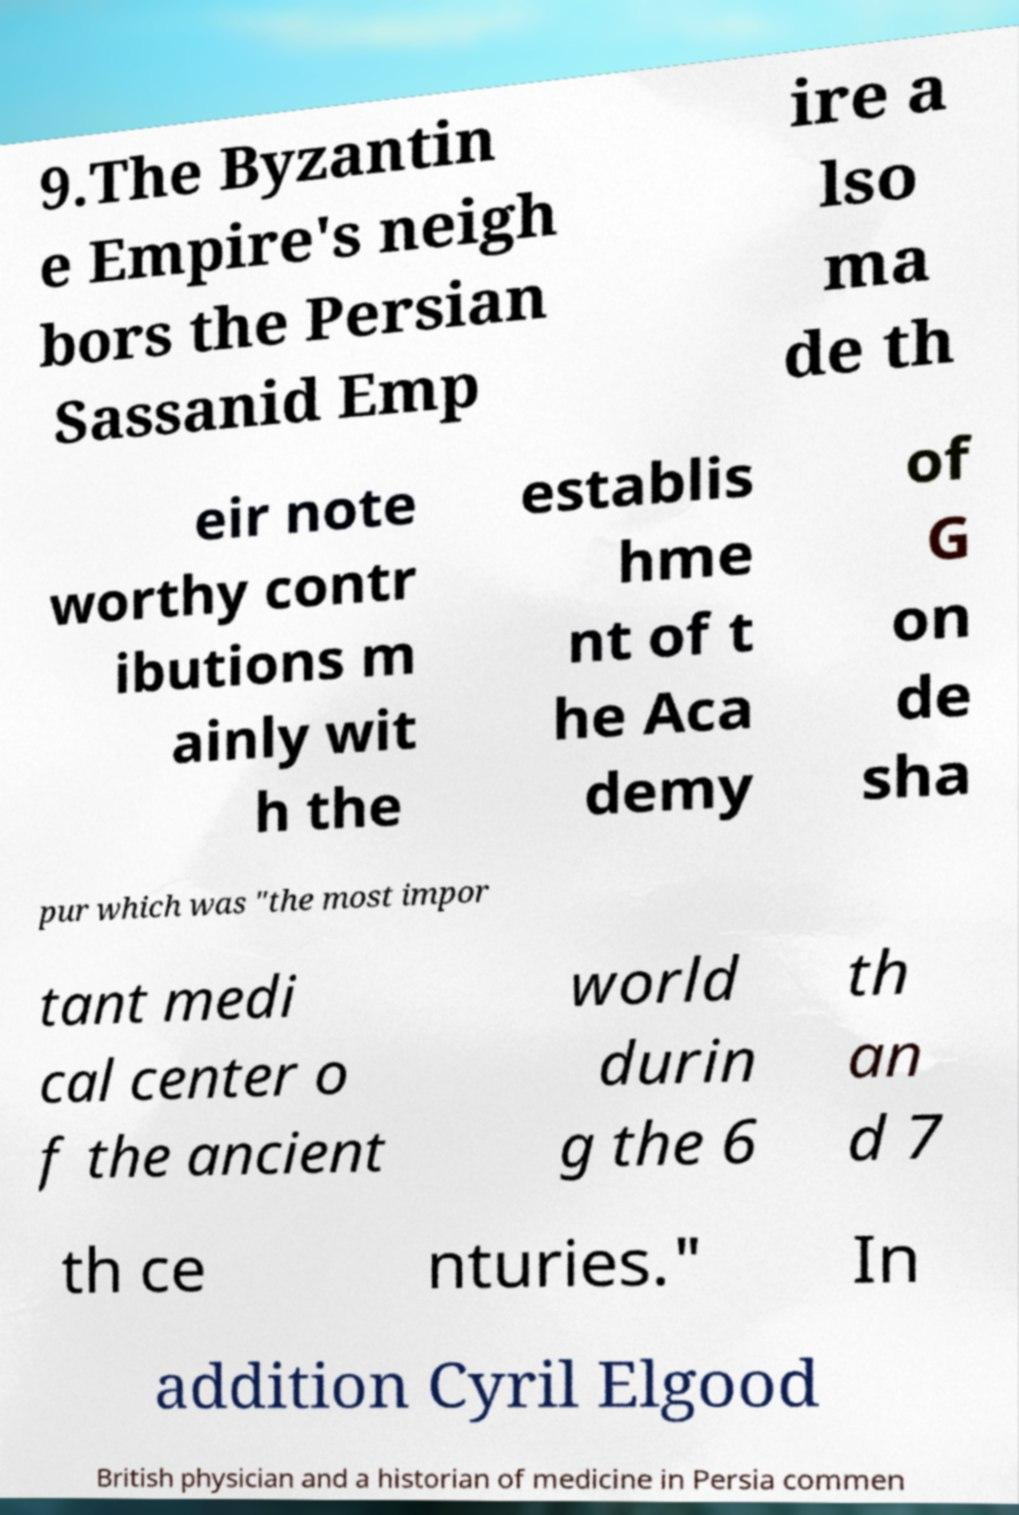I need the written content from this picture converted into text. Can you do that? 9.The Byzantin e Empire's neigh bors the Persian Sassanid Emp ire a lso ma de th eir note worthy contr ibutions m ainly wit h the establis hme nt of t he Aca demy of G on de sha pur which was "the most impor tant medi cal center o f the ancient world durin g the 6 th an d 7 th ce nturies." In addition Cyril Elgood British physician and a historian of medicine in Persia commen 